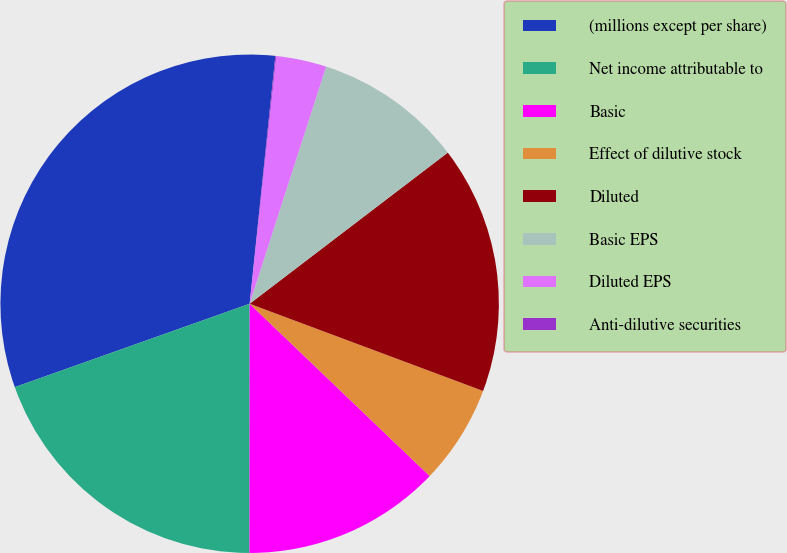Convert chart. <chart><loc_0><loc_0><loc_500><loc_500><pie_chart><fcel>(millions except per share)<fcel>Net income attributable to<fcel>Basic<fcel>Effect of dilutive stock<fcel>Diluted<fcel>Basic EPS<fcel>Diluted EPS<fcel>Anti-dilutive securities<nl><fcel>32.07%<fcel>19.56%<fcel>12.86%<fcel>6.46%<fcel>16.06%<fcel>9.66%<fcel>3.26%<fcel>0.06%<nl></chart> 